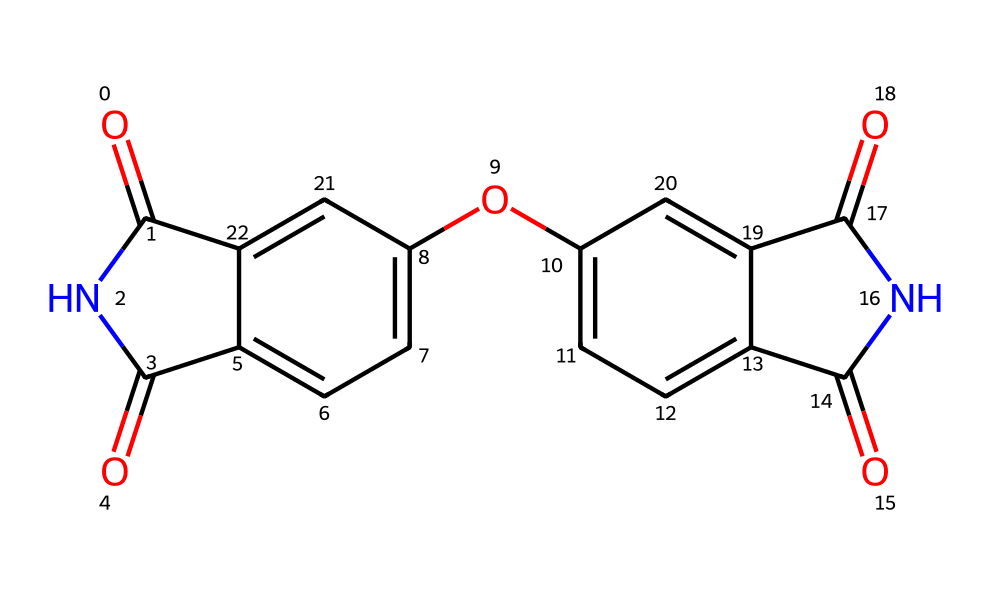What is the functional group present in this structure? The structure contains nitrogen (N) atoms bonded with carbonyl groups (O=C). This combination of carbonyls directly attached to nitrogen characterizes imides.
Answer: imide How many carbon atoms are present in this molecule? By analyzing the SMILES representation, there are a total of 14 carbon atoms, including those in the rings and attached groups.
Answer: 14 What is the position of the hydroxyl group in relation to the phenyl ring? The hydroxyl group (-OH) appears directly attached to one of the phenyl rings, specifically on a carbon next to the imide functionalities, indicating its ortho position.
Answer: ortho How many nitrogen atoms are present in the molecule? Counting the nitrogen atoms in the structure derived from the SMILES, we find there are two nitrogen atoms that are part of the imide groups.
Answer: 2 What type of intermolecular forces would be prominent in imide-based adhesives? Imides can engage in hydrogen bonding due to the presence of carbonyl and amine functionalities, enhancing their adhesive properties.
Answer: hydrogen bonding What is the primary use of imide compounds in industrial applications? Imide compounds are commonly utilized as high-performance adhesives because of their thermal and chemical stability.
Answer: adhesives Which aspect of the molecular structure contributes to the thermal stability of imides? The rigid ring structure of imides, along with the strong covalent bonds present in the aromatic systems, contributes significantly to their thermal stability.
Answer: rigid ring structure 